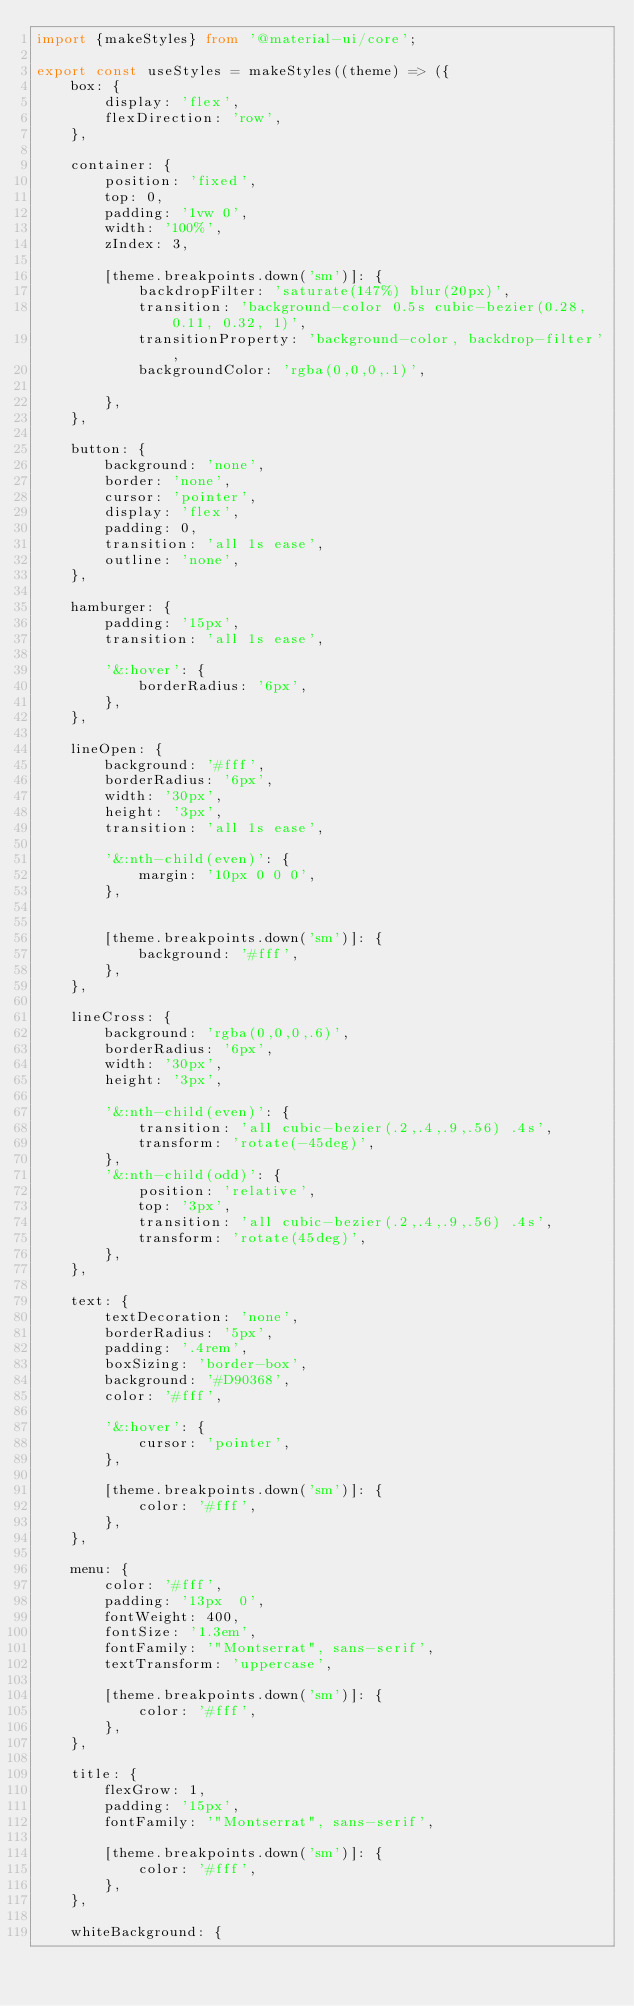Convert code to text. <code><loc_0><loc_0><loc_500><loc_500><_TypeScript_>import {makeStyles} from '@material-ui/core';

export const useStyles = makeStyles((theme) => ({
    box: {
        display: 'flex',
        flexDirection: 'row',
    },

    container: {
        position: 'fixed',
        top: 0,
        padding: '1vw 0',
        width: '100%',
        zIndex: 3,

        [theme.breakpoints.down('sm')]: {
            backdropFilter: 'saturate(147%) blur(20px)',
            transition: 'background-color 0.5s cubic-bezier(0.28, 0.11, 0.32, 1)',
            transitionProperty: 'background-color, backdrop-filter',
            backgroundColor: 'rgba(0,0,0,.1)',

        },
    },

    button: {
        background: 'none',
        border: 'none',
        cursor: 'pointer',
        display: 'flex',
        padding: 0,
        transition: 'all 1s ease',
        outline: 'none',
    },

    hamburger: {
        padding: '15px',
        transition: 'all 1s ease',

        '&:hover': {
            borderRadius: '6px',
        },
    },

    lineOpen: {
        background: '#fff',
        borderRadius: '6px',
        width: '30px',
        height: '3px',
        transition: 'all 1s ease',

        '&:nth-child(even)': {
            margin: '10px 0 0 0',
        },


        [theme.breakpoints.down('sm')]: {
            background: '#fff',
        },
    },

    lineCross: {
        background: 'rgba(0,0,0,.6)',
        borderRadius: '6px',
        width: '30px',
        height: '3px',

        '&:nth-child(even)': {
            transition: 'all cubic-bezier(.2,.4,.9,.56) .4s',
            transform: 'rotate(-45deg)',
        },
        '&:nth-child(odd)': {
            position: 'relative',
            top: '3px',
            transition: 'all cubic-bezier(.2,.4,.9,.56) .4s',
            transform: 'rotate(45deg)',
        },
    },

    text: {
        textDecoration: 'none',
        borderRadius: '5px',
        padding: '.4rem',
        boxSizing: 'border-box',
        background: '#D90368',
        color: '#fff',

        '&:hover': {
            cursor: 'pointer',
        },

        [theme.breakpoints.down('sm')]: {
            color: '#fff',
        },
    },

    menu: {
        color: '#fff',
        padding: '13px  0',
        fontWeight: 400,
        fontSize: '1.3em',
        fontFamily: '"Montserrat", sans-serif',
        textTransform: 'uppercase',

        [theme.breakpoints.down('sm')]: {
            color: '#fff',
        },
    },

    title: {
        flexGrow: 1,
        padding: '15px',
        fontFamily: '"Montserrat", sans-serif',

        [theme.breakpoints.down('sm')]: {
            color: '#fff',
        },
    },

    whiteBackground: {</code> 